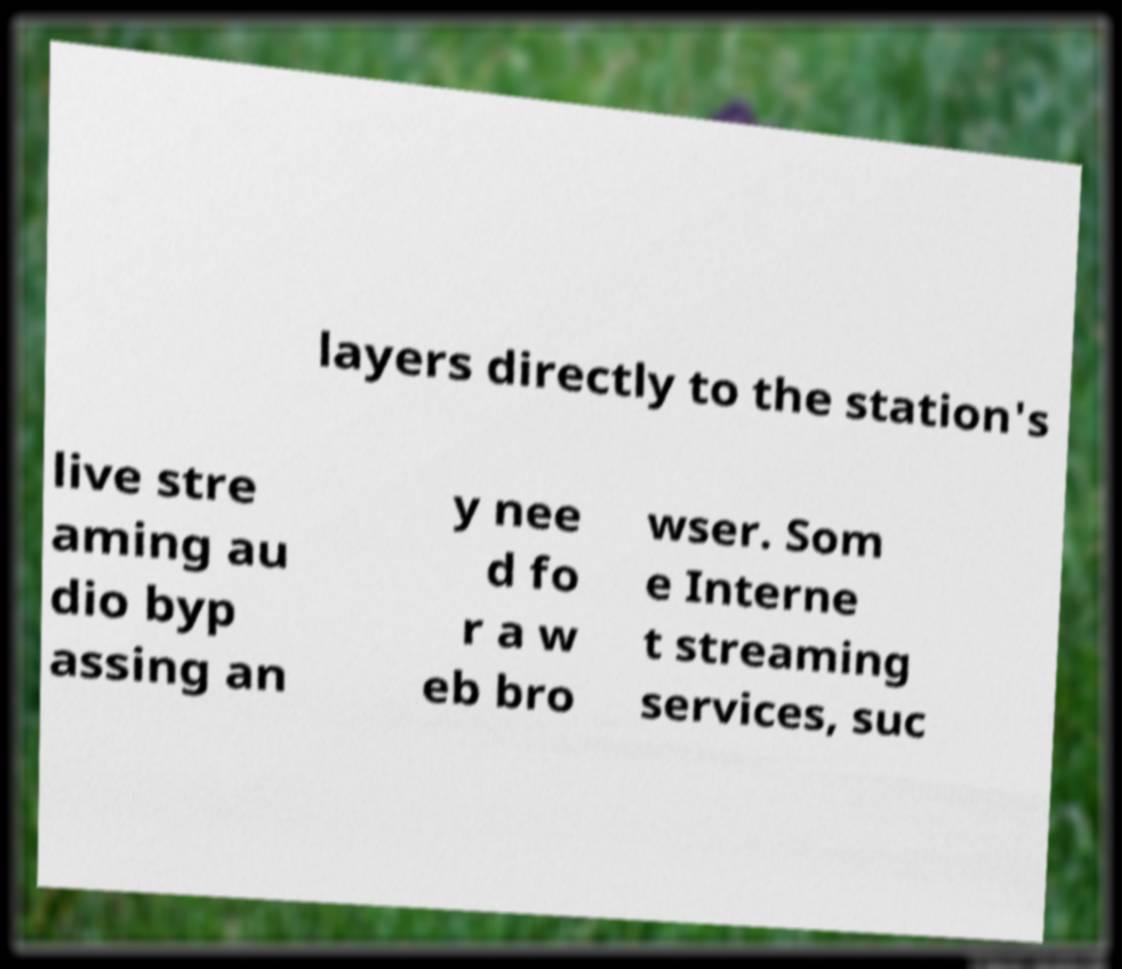Please identify and transcribe the text found in this image. layers directly to the station's live stre aming au dio byp assing an y nee d fo r a w eb bro wser. Som e Interne t streaming services, suc 